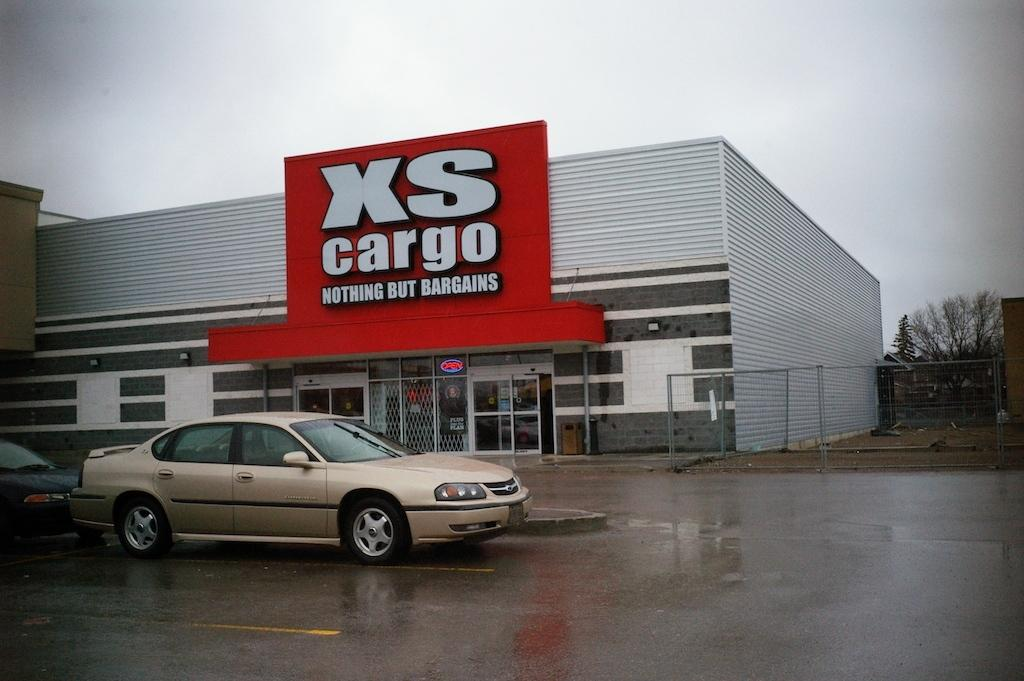What can be seen at the bottom of the image? There are cars on the road at the bottom of the image. What structures are visible in the background of the image? There is a shed, a board, a fence, and a tree visible in the background of the image. What else can be seen in the background of the image? The sky is visible in the background of the image. What type of thread is hanging from the tree in the image? There is no thread hanging from the tree in the image; only the tree and other background elements are present. What is the value of the board in the image? The value of the board cannot be determined from the image, as it is not a tangible object with a monetary value. 